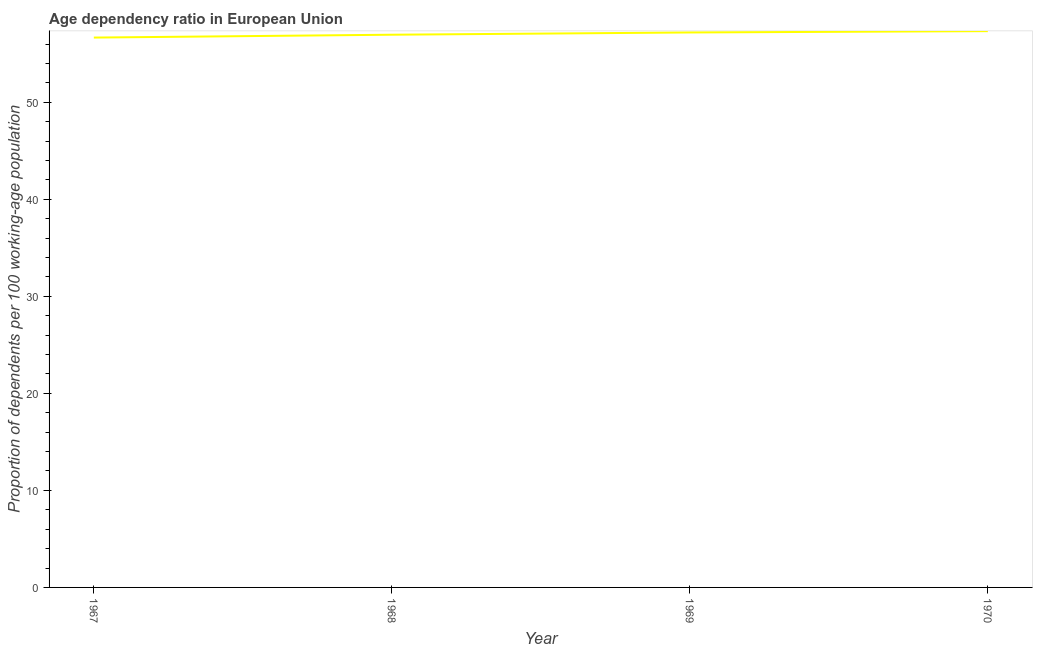What is the age dependency ratio in 1969?
Provide a short and direct response. 57.19. Across all years, what is the maximum age dependency ratio?
Make the answer very short. 57.33. Across all years, what is the minimum age dependency ratio?
Your response must be concise. 56.66. In which year was the age dependency ratio maximum?
Your answer should be very brief. 1970. In which year was the age dependency ratio minimum?
Make the answer very short. 1967. What is the sum of the age dependency ratio?
Give a very brief answer. 228.14. What is the difference between the age dependency ratio in 1968 and 1969?
Provide a short and direct response. -0.23. What is the average age dependency ratio per year?
Give a very brief answer. 57.04. What is the median age dependency ratio?
Give a very brief answer. 57.08. In how many years, is the age dependency ratio greater than 8 ?
Your answer should be compact. 4. Do a majority of the years between 1970 and 1969 (inclusive) have age dependency ratio greater than 34 ?
Your answer should be very brief. No. What is the ratio of the age dependency ratio in 1968 to that in 1970?
Give a very brief answer. 0.99. Is the age dependency ratio in 1967 less than that in 1969?
Keep it short and to the point. Yes. What is the difference between the highest and the second highest age dependency ratio?
Provide a short and direct response. 0.14. Is the sum of the age dependency ratio in 1969 and 1970 greater than the maximum age dependency ratio across all years?
Make the answer very short. Yes. What is the difference between the highest and the lowest age dependency ratio?
Make the answer very short. 0.66. Does the age dependency ratio monotonically increase over the years?
Keep it short and to the point. Yes. How many lines are there?
Your answer should be compact. 1. Does the graph contain any zero values?
Provide a succinct answer. No. Does the graph contain grids?
Offer a very short reply. No. What is the title of the graph?
Your response must be concise. Age dependency ratio in European Union. What is the label or title of the Y-axis?
Give a very brief answer. Proportion of dependents per 100 working-age population. What is the Proportion of dependents per 100 working-age population of 1967?
Provide a succinct answer. 56.66. What is the Proportion of dependents per 100 working-age population of 1968?
Provide a short and direct response. 56.96. What is the Proportion of dependents per 100 working-age population of 1969?
Give a very brief answer. 57.19. What is the Proportion of dependents per 100 working-age population of 1970?
Offer a very short reply. 57.33. What is the difference between the Proportion of dependents per 100 working-age population in 1967 and 1968?
Your answer should be very brief. -0.3. What is the difference between the Proportion of dependents per 100 working-age population in 1967 and 1969?
Your answer should be very brief. -0.53. What is the difference between the Proportion of dependents per 100 working-age population in 1967 and 1970?
Ensure brevity in your answer.  -0.66. What is the difference between the Proportion of dependents per 100 working-age population in 1968 and 1969?
Make the answer very short. -0.23. What is the difference between the Proportion of dependents per 100 working-age population in 1968 and 1970?
Give a very brief answer. -0.37. What is the difference between the Proportion of dependents per 100 working-age population in 1969 and 1970?
Offer a very short reply. -0.14. What is the ratio of the Proportion of dependents per 100 working-age population in 1967 to that in 1969?
Your answer should be very brief. 0.99. What is the ratio of the Proportion of dependents per 100 working-age population in 1968 to that in 1969?
Your response must be concise. 1. What is the ratio of the Proportion of dependents per 100 working-age population in 1969 to that in 1970?
Provide a short and direct response. 1. 